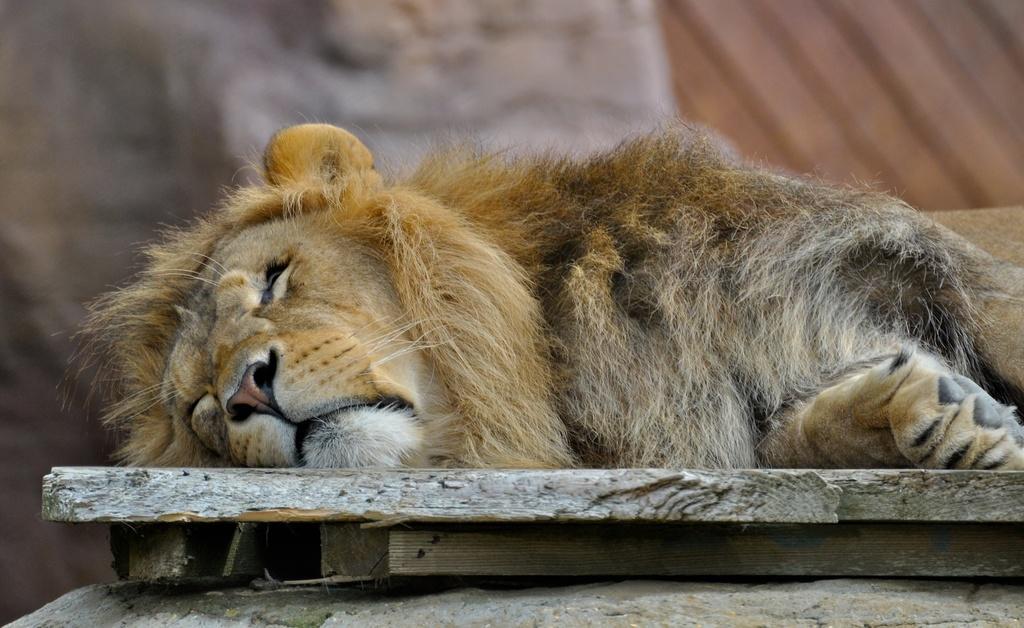How would you summarize this image in a sentence or two? In this image, I can see a lion lying on a wooden object. The background looks blurry. 